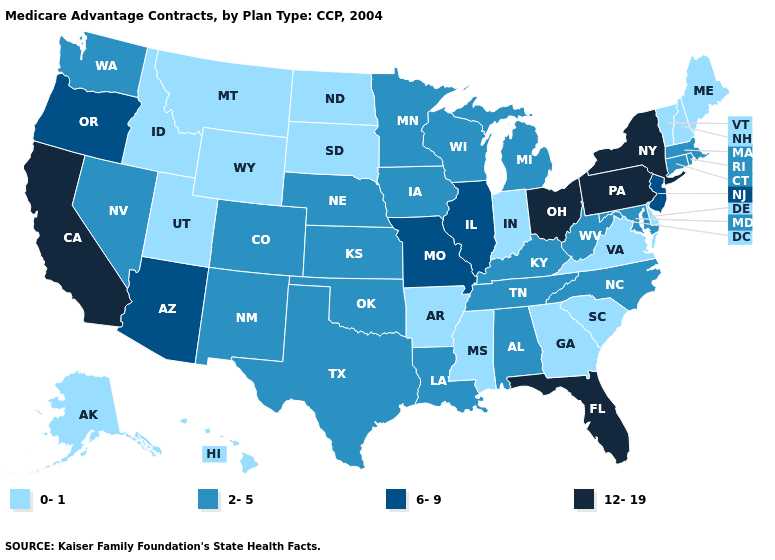Name the states that have a value in the range 0-1?
Keep it brief. Alaska, Arkansas, Delaware, Georgia, Hawaii, Idaho, Indiana, Maine, Mississippi, Montana, North Dakota, New Hampshire, South Carolina, South Dakota, Utah, Virginia, Vermont, Wyoming. Name the states that have a value in the range 6-9?
Be succinct. Arizona, Illinois, Missouri, New Jersey, Oregon. What is the value of Montana?
Write a very short answer. 0-1. Among the states that border West Virginia , does Virginia have the highest value?
Write a very short answer. No. Name the states that have a value in the range 12-19?
Concise answer only. California, Florida, New York, Ohio, Pennsylvania. Is the legend a continuous bar?
Give a very brief answer. No. What is the value of Tennessee?
Short answer required. 2-5. Among the states that border Massachusetts , which have the highest value?
Give a very brief answer. New York. Does West Virginia have the lowest value in the South?
Keep it brief. No. Which states hav the highest value in the West?
Concise answer only. California. Does Ohio have a higher value than Florida?
Answer briefly. No. Which states have the highest value in the USA?
Write a very short answer. California, Florida, New York, Ohio, Pennsylvania. What is the lowest value in states that border Rhode Island?
Keep it brief. 2-5. How many symbols are there in the legend?
Concise answer only. 4. What is the highest value in states that border Rhode Island?
Quick response, please. 2-5. 